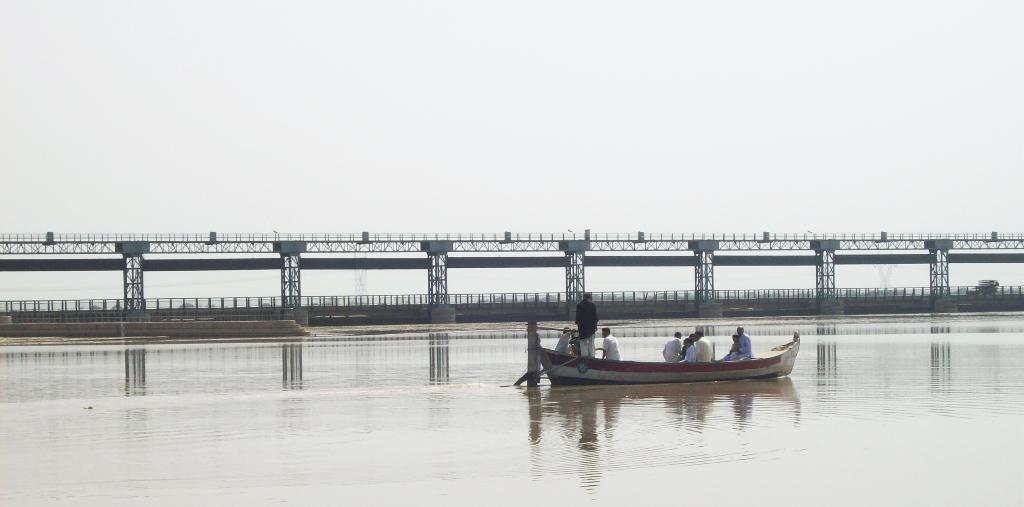Could you give a brief overview of what you see in this image? In the center of the image there are persons in the boat sailing on the river. In the background we can see bridge, water and sky. 